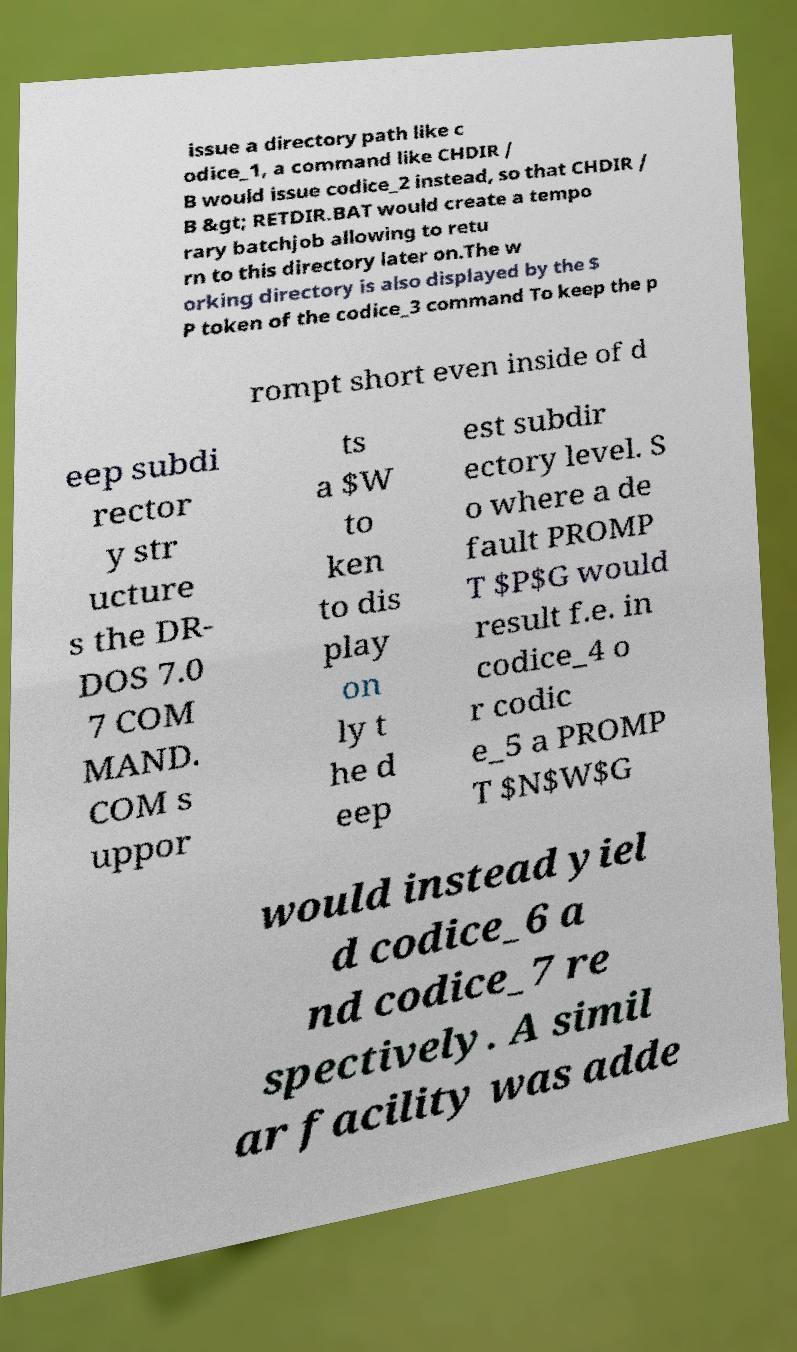Please read and relay the text visible in this image. What does it say? issue a directory path like c odice_1, a command like CHDIR / B would issue codice_2 instead, so that CHDIR / B &gt; RETDIR.BAT would create a tempo rary batchjob allowing to retu rn to this directory later on.The w orking directory is also displayed by the $ P token of the codice_3 command To keep the p rompt short even inside of d eep subdi rector y str ucture s the DR- DOS 7.0 7 COM MAND. COM s uppor ts a $W to ken to dis play on ly t he d eep est subdir ectory level. S o where a de fault PROMP T $P$G would result f.e. in codice_4 o r codic e_5 a PROMP T $N$W$G would instead yiel d codice_6 a nd codice_7 re spectively. A simil ar facility was adde 